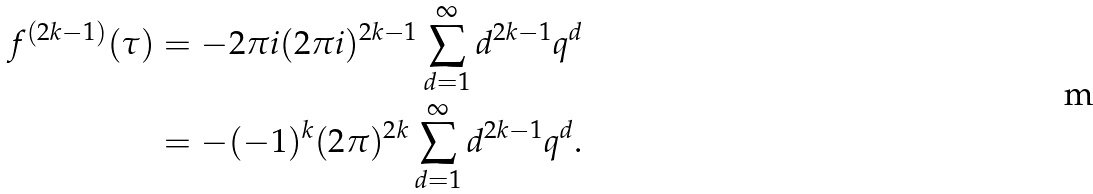<formula> <loc_0><loc_0><loc_500><loc_500>f ^ { ( 2 k - 1 ) } ( \tau ) & = - 2 \pi i ( 2 \pi i ) ^ { 2 k - 1 } \sum _ { d = 1 } ^ { \infty } d ^ { 2 k - 1 } q ^ { d } \\ & = - ( - 1 ) ^ { k } ( 2 \pi ) ^ { 2 k } \sum _ { d = 1 } ^ { \infty } d ^ { 2 k - 1 } q ^ { d } .</formula> 